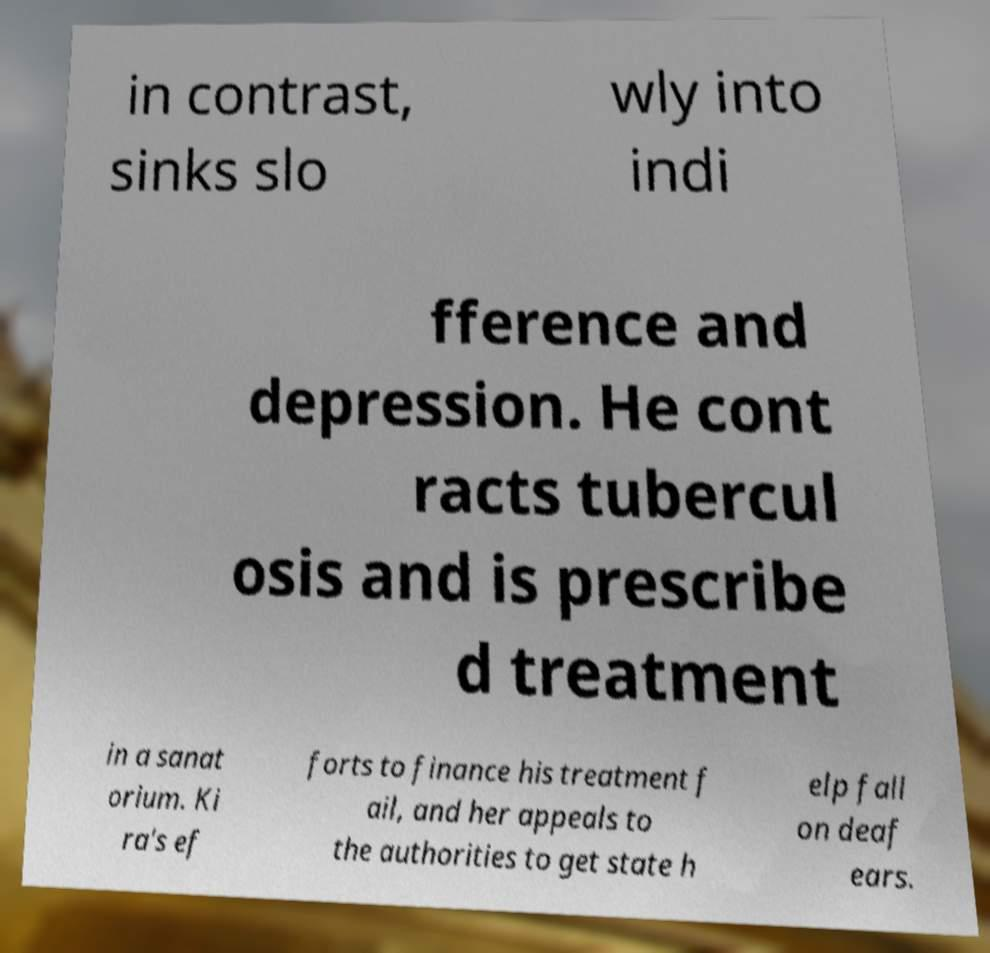There's text embedded in this image that I need extracted. Can you transcribe it verbatim? in contrast, sinks slo wly into indi fference and depression. He cont racts tubercul osis and is prescribe d treatment in a sanat orium. Ki ra's ef forts to finance his treatment f ail, and her appeals to the authorities to get state h elp fall on deaf ears. 